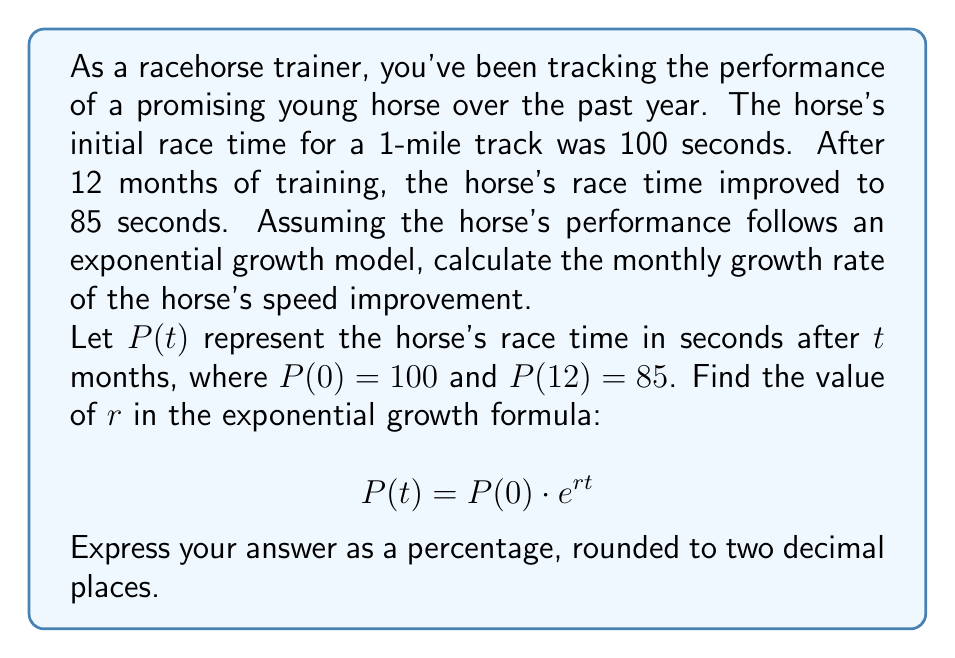What is the answer to this math problem? To solve this problem, we'll use the exponential growth formula and the given information:

1) Initial condition: $P(0) = 100$ seconds
2) After 12 months: $P(12) = 85$ seconds
3) Exponential growth formula: $P(t) = P(0) \cdot e^{rt}$

Let's follow these steps:

Step 1: Substitute the known values into the exponential growth formula:
$$85 = 100 \cdot e^{12r}$$

Step 2: Divide both sides by 100:
$$0.85 = e^{12r}$$

Step 3: Take the natural logarithm of both sides:
$$\ln(0.85) = \ln(e^{12r})$$

Step 4: Simplify the right side using the logarithm property $\ln(e^x) = x$:
$$\ln(0.85) = 12r$$

Step 5: Solve for $r$:
$$r = \frac{\ln(0.85)}{12}$$

Step 6: Calculate the value of $r$:
$$r = \frac{-0.1625}{12} \approx -0.0135$$

Step 7: Convert to a percentage by multiplying by 100:
$$r \approx -1.35\%$$

The negative value indicates that the race time is decreasing, which means the horse's speed is improving.
Answer: The monthly growth rate of the horse's speed improvement is approximately -1.35%. 